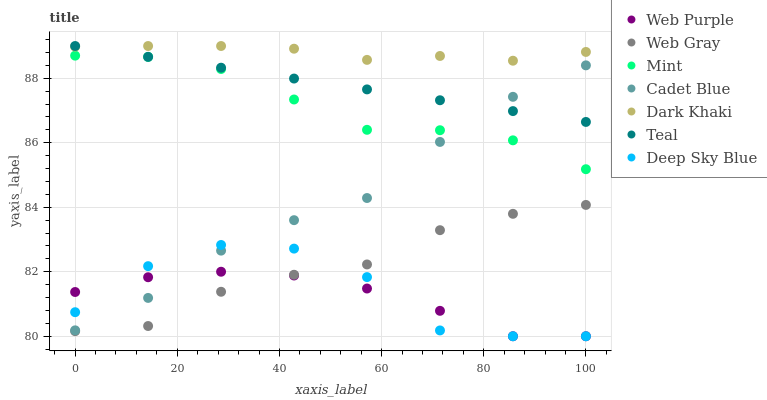Does Web Purple have the minimum area under the curve?
Answer yes or no. Yes. Does Dark Khaki have the maximum area under the curve?
Answer yes or no. Yes. Does Deep Sky Blue have the minimum area under the curve?
Answer yes or no. No. Does Deep Sky Blue have the maximum area under the curve?
Answer yes or no. No. Is Teal the smoothest?
Answer yes or no. Yes. Is Deep Sky Blue the roughest?
Answer yes or no. Yes. Is Dark Khaki the smoothest?
Answer yes or no. No. Is Dark Khaki the roughest?
Answer yes or no. No. Does Deep Sky Blue have the lowest value?
Answer yes or no. Yes. Does Dark Khaki have the lowest value?
Answer yes or no. No. Does Teal have the highest value?
Answer yes or no. Yes. Does Deep Sky Blue have the highest value?
Answer yes or no. No. Is Web Purple less than Teal?
Answer yes or no. Yes. Is Mint greater than Deep Sky Blue?
Answer yes or no. Yes. Does Deep Sky Blue intersect Cadet Blue?
Answer yes or no. Yes. Is Deep Sky Blue less than Cadet Blue?
Answer yes or no. No. Is Deep Sky Blue greater than Cadet Blue?
Answer yes or no. No. Does Web Purple intersect Teal?
Answer yes or no. No. 